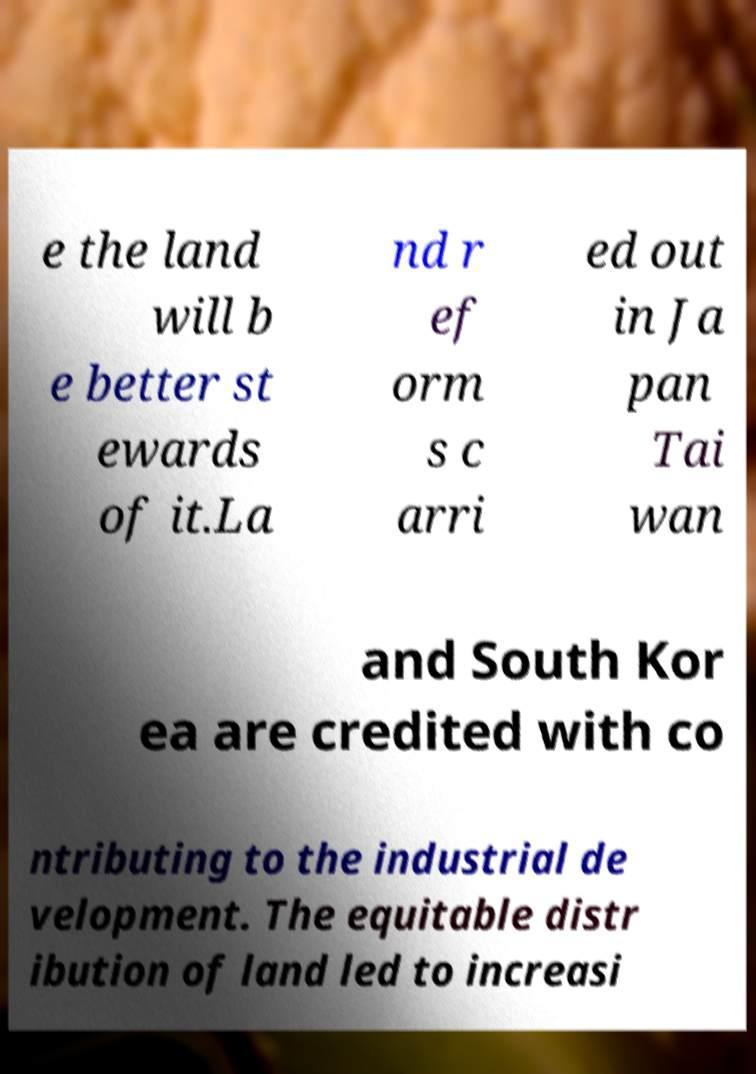I need the written content from this picture converted into text. Can you do that? e the land will b e better st ewards of it.La nd r ef orm s c arri ed out in Ja pan Tai wan and South Kor ea are credited with co ntributing to the industrial de velopment. The equitable distr ibution of land led to increasi 